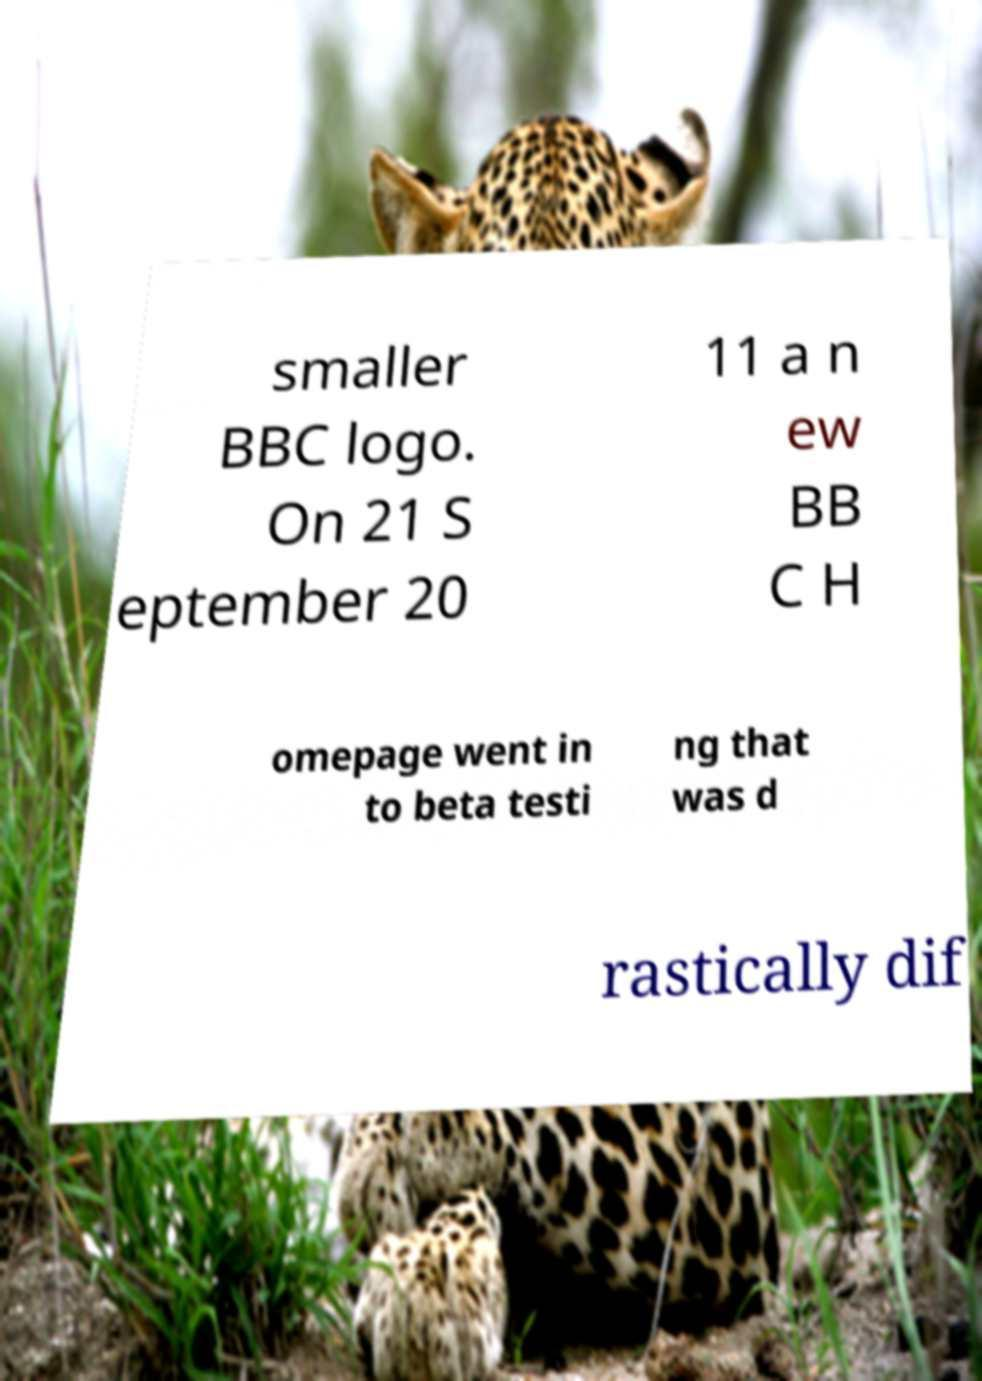Could you assist in decoding the text presented in this image and type it out clearly? smaller BBC logo. On 21 S eptember 20 11 a n ew BB C H omepage went in to beta testi ng that was d rastically dif 